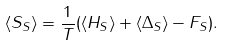<formula> <loc_0><loc_0><loc_500><loc_500>\left \langle S _ { S } \right \rangle = \frac { 1 } { T } ( \left \langle H _ { S } \right \rangle + \left \langle \Delta _ { S } \right \rangle - F _ { S } ) .</formula> 